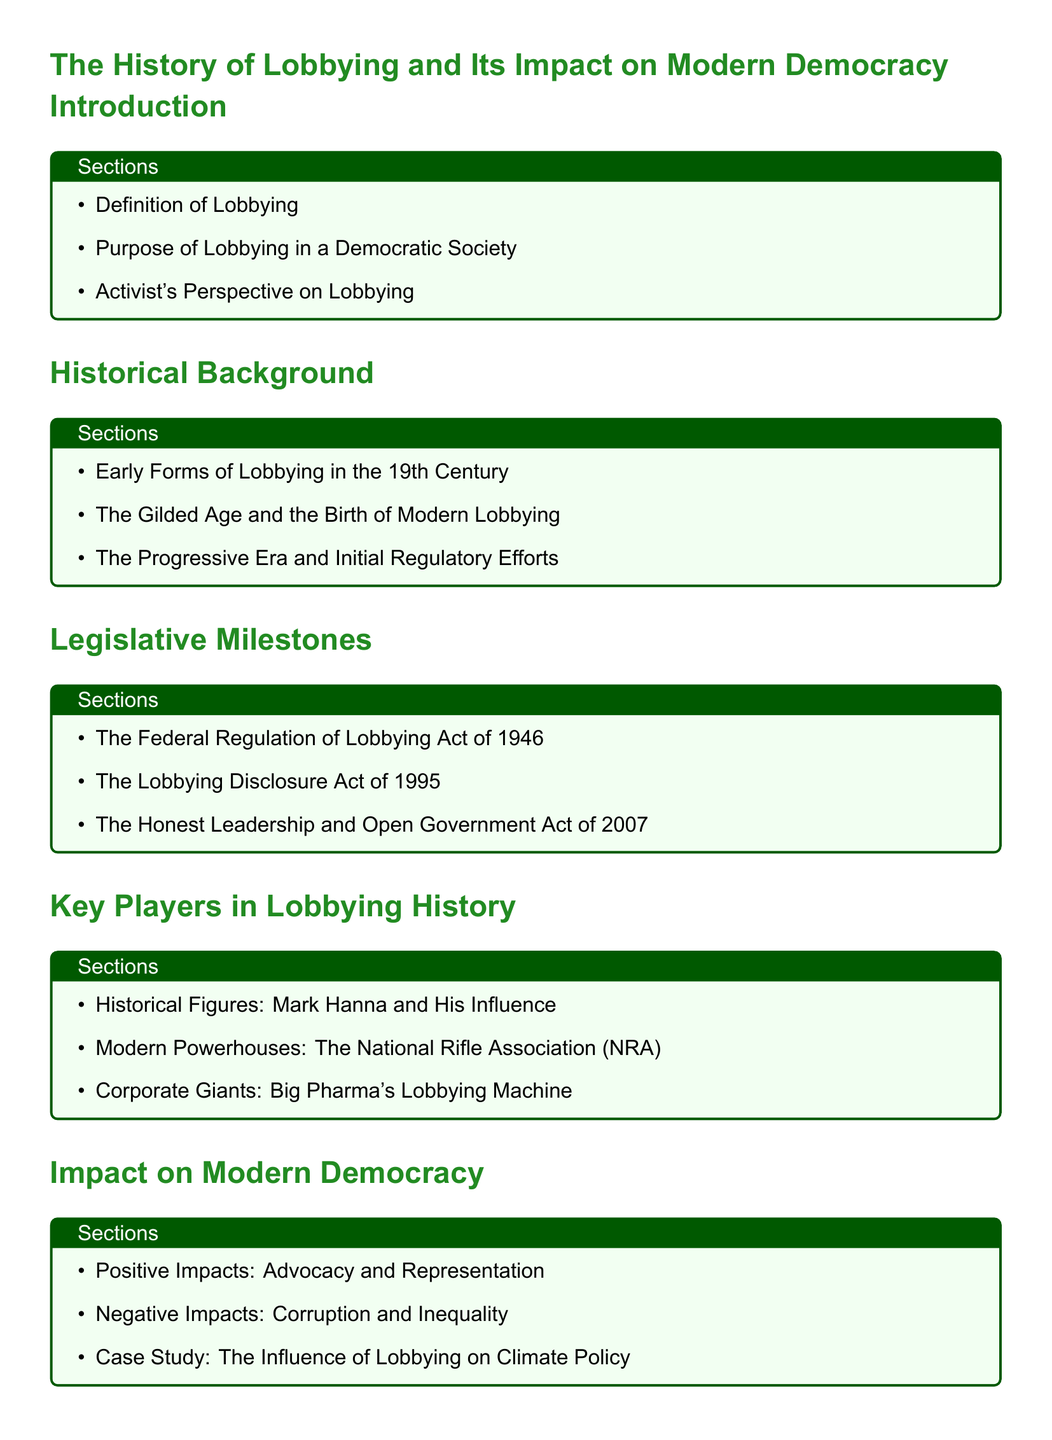What is the title of the document? The title of the document is defined in the table of contents as "The History of Lobbying and Its Impact on Modern Democracy."
Answer: The History of Lobbying and Its Impact on Modern Democracy Who is a historical figure mentioned in the document? The document lists Mark Hanna as a key player in lobbying history.
Answer: Mark Hanna What year was the Federal Regulation of Lobbying Act enacted? The Federal Regulation of Lobbying Act was enacted in 1946, as mentioned in the Legislative Milestones section.
Answer: 1946 Which act was introduced in 2007? The Honest Leadership and Open Government Act was introduced in 2007 according to the Legislative Milestones section.
Answer: Honest Leadership and Open Government Act What is one of the positive impacts of lobbying mentioned? The document notes that one of the positive impacts of lobbying is advocacy and representation in a democratic society.
Answer: Advocacy and Representation What section discusses grassroots movements? The section "Regulatory and Reform Efforts" discusses grassroots movements against lobbyist influence.
Answer: Regulatory and Reform Efforts Which era saw the birth of modern lobbying? The Gilded Age is noted as the era when modern lobbying began to take shape.
Answer: The Gilded Age What is the main focus of the conclusion section? The conclusion section focuses on the future of lobbying and democratic integrity as well as an activist's call to action.
Answer: The Future of Lobbying and Democratic Integrity 